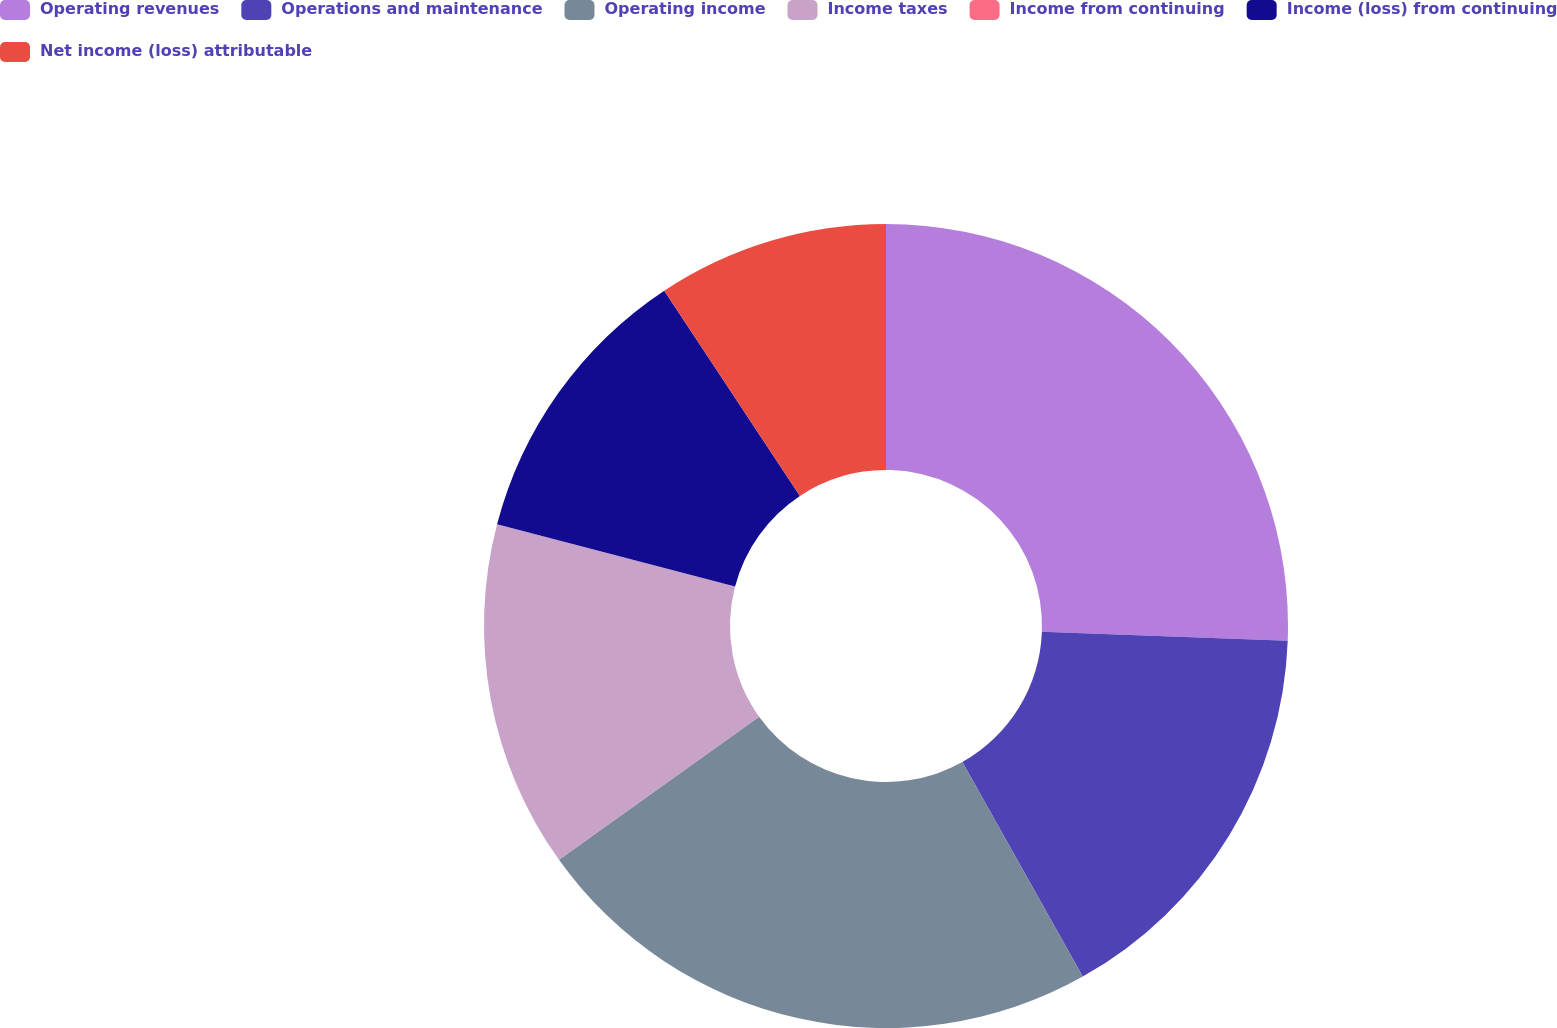<chart> <loc_0><loc_0><loc_500><loc_500><pie_chart><fcel>Operating revenues<fcel>Operations and maintenance<fcel>Operating income<fcel>Income taxes<fcel>Income from continuing<fcel>Income (loss) from continuing<fcel>Net income (loss) attributable<nl><fcel>25.58%<fcel>16.28%<fcel>23.26%<fcel>13.95%<fcel>0.0%<fcel>11.63%<fcel>9.3%<nl></chart> 